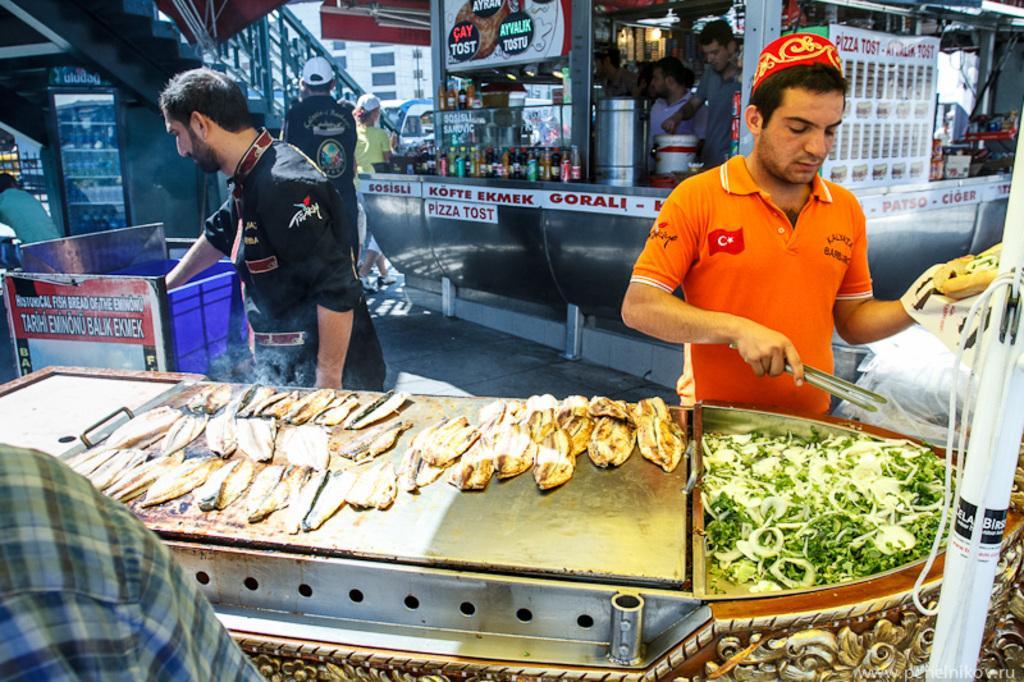Can you describe this image briefly? In this image I can see few people standing. In front the person is wearing orange color shirt and holding some object and I can also see few food items on the steel surface and the food items are in green, brown and cream color. In the background I can see few stores, boards and I can see few buildings. 